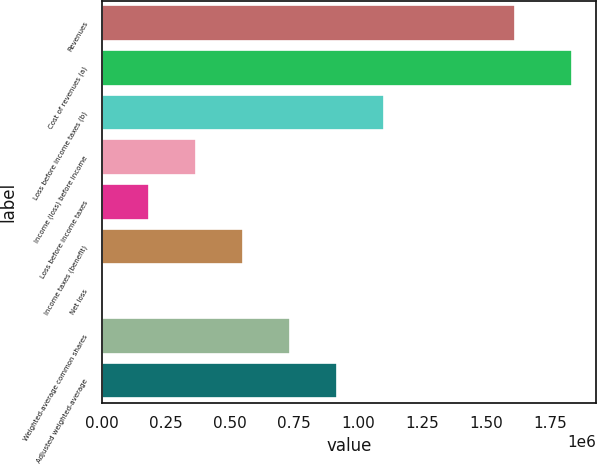Convert chart to OTSL. <chart><loc_0><loc_0><loc_500><loc_500><bar_chart><fcel>Revenues<fcel>Cost of revenues (a)<fcel>Loss before income taxes (b)<fcel>Income (loss) before income<fcel>Loss before income taxes<fcel>Income taxes (benefit)<fcel>Net loss<fcel>Weighted-average common shares<fcel>Adjusted weighted-average<nl><fcel>1.61167e+06<fcel>1.83681e+06<fcel>1.10209e+06<fcel>367363<fcel>183682<fcel>551044<fcel>1.33<fcel>734724<fcel>918405<nl></chart> 